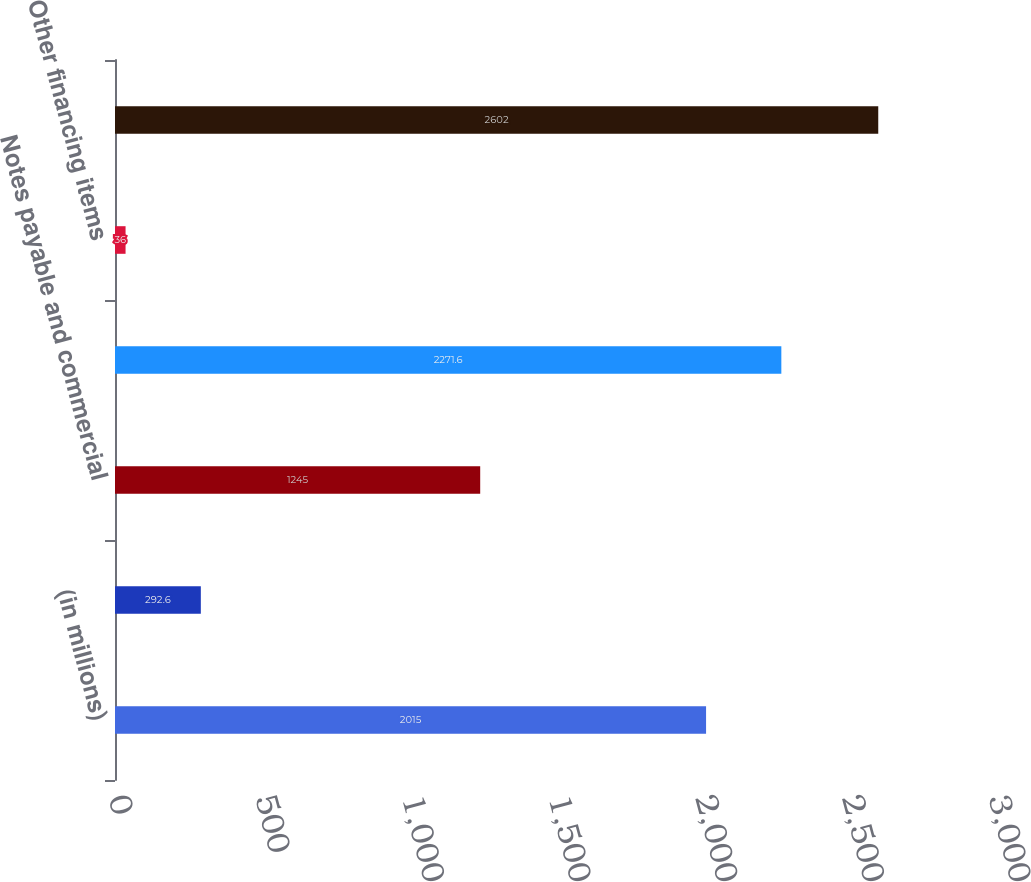Convert chart to OTSL. <chart><loc_0><loc_0><loc_500><loc_500><bar_chart><fcel>(in millions)<fcel>Issuances (Repayments) of<fcel>Notes payable and commercial<fcel>Dividends paid<fcel>Other financing items<fcel>Net cash provided by (used in)<nl><fcel>2015<fcel>292.6<fcel>1245<fcel>2271.6<fcel>36<fcel>2602<nl></chart> 